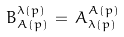Convert formula to latex. <formula><loc_0><loc_0><loc_500><loc_500>B _ { A ( p ) } ^ { \lambda ( p ) } \, = \, A ^ { A ( p ) } _ { \lambda ( p ) }</formula> 